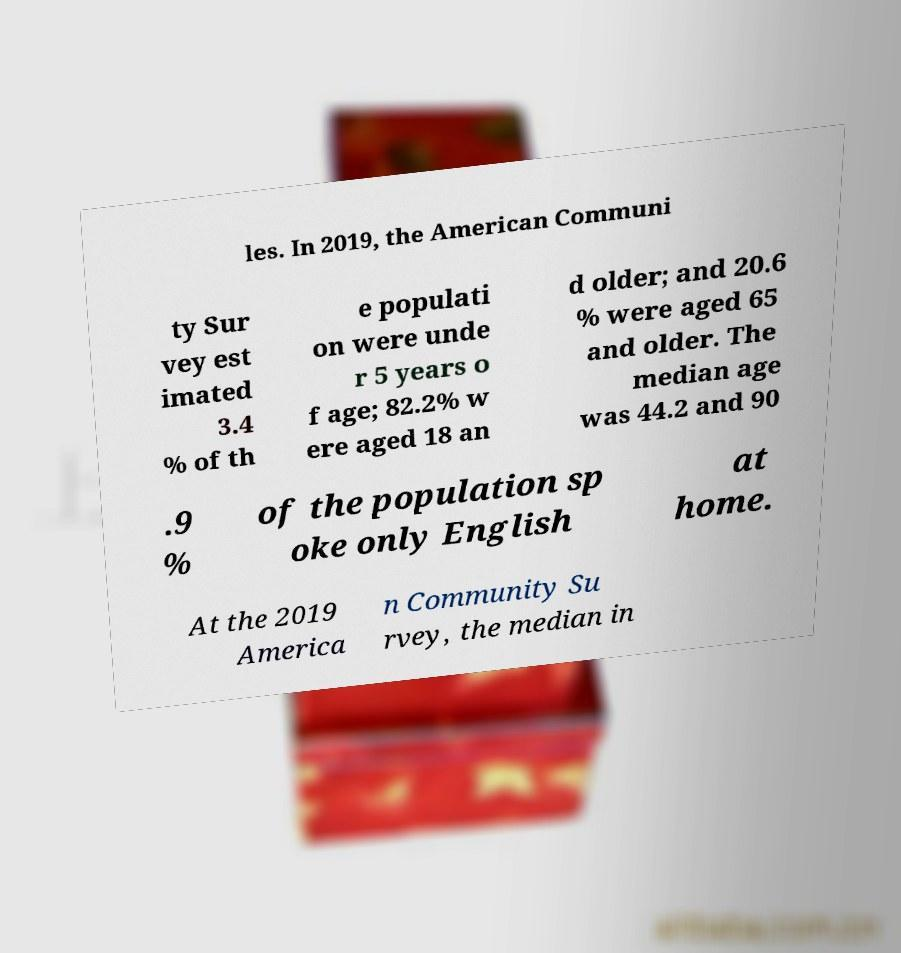Please identify and transcribe the text found in this image. les. In 2019, the American Communi ty Sur vey est imated 3.4 % of th e populati on were unde r 5 years o f age; 82.2% w ere aged 18 an d older; and 20.6 % were aged 65 and older. The median age was 44.2 and 90 .9 % of the population sp oke only English at home. At the 2019 America n Community Su rvey, the median in 